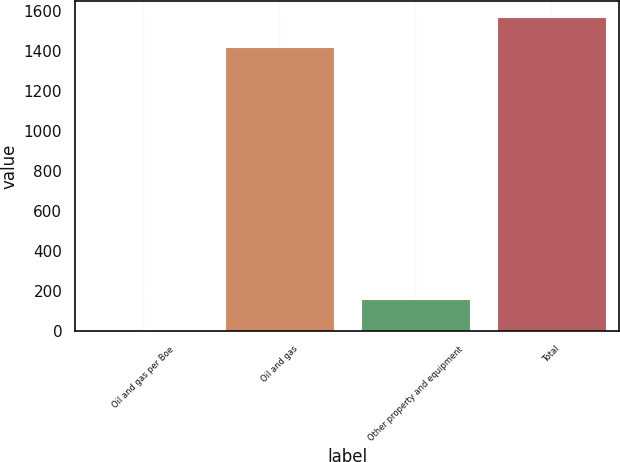Convert chart. <chart><loc_0><loc_0><loc_500><loc_500><bar_chart><fcel>Oil and gas per Boe<fcel>Oil and gas<fcel>Other property and equipment<fcel>Total<nl><fcel>7.15<fcel>1419<fcel>159.34<fcel>1571.18<nl></chart> 